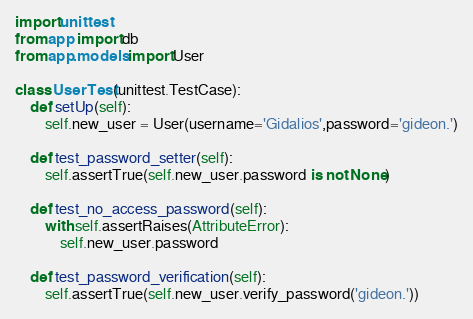<code> <loc_0><loc_0><loc_500><loc_500><_Python_>import unittest
from app import db
from app.models import User

class UserTest(unittest.TestCase):
    def setUp(self):
        self.new_user = User(username='Gidalios',password='gideon.')

    def test_password_setter(self):
        self.assertTrue(self.new_user.password is not None)

    def test_no_access_password(self):
        with self.assertRaises(AttributeError):
            self.new_user.password

    def test_password_verification(self):
        self.assertTrue(self.new_user.verify_password('gideon.'))</code> 